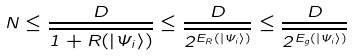Convert formula to latex. <formula><loc_0><loc_0><loc_500><loc_500>N \leq \frac { D } { \overline { 1 + R ( | \Psi _ { i } \rangle ) } } \leq \frac { D } { \overline { 2 ^ { E _ { R } ( | \Psi _ { i } \rangle ) } } } \leq \frac { D } { \overline { 2 ^ { E _ { g } ( | \Psi _ { i } \rangle ) } } }</formula> 